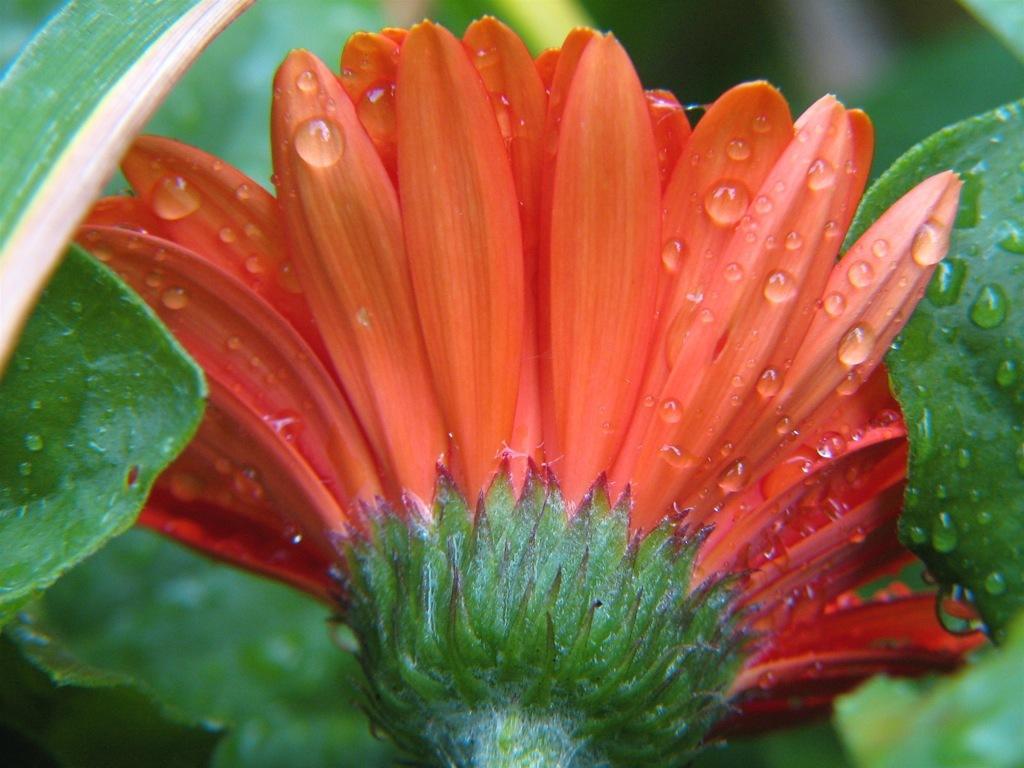Please provide a concise description of this image. In this image I can see an orange colour flower and green colour leaves on the both side of it. 